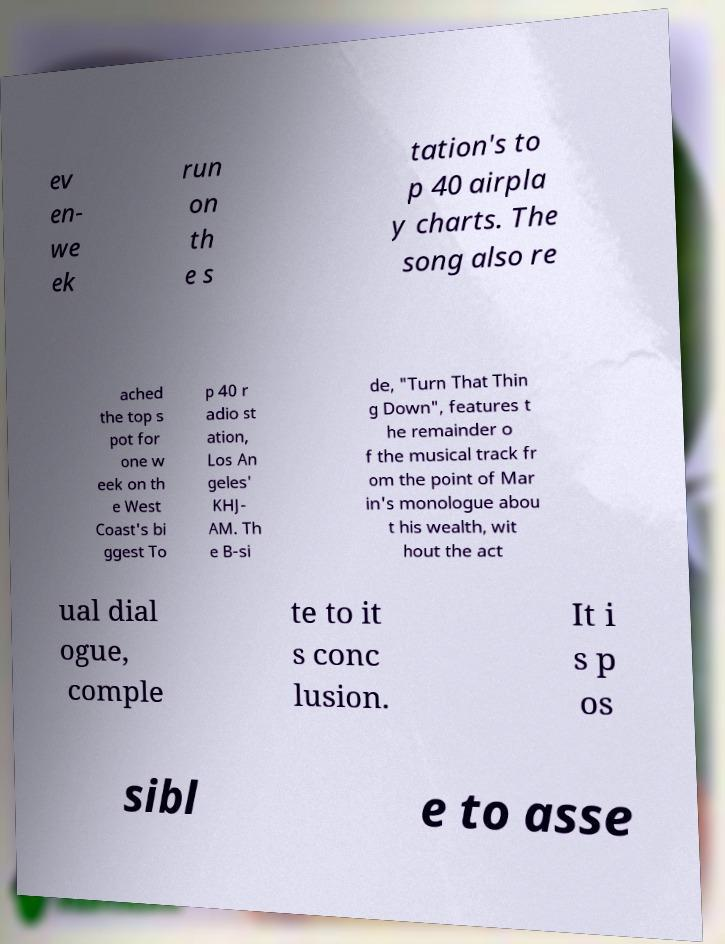Can you accurately transcribe the text from the provided image for me? ev en- we ek run on th e s tation's to p 40 airpla y charts. The song also re ached the top s pot for one w eek on th e West Coast's bi ggest To p 40 r adio st ation, Los An geles' KHJ- AM. Th e B-si de, "Turn That Thin g Down", features t he remainder o f the musical track fr om the point of Mar in's monologue abou t his wealth, wit hout the act ual dial ogue, comple te to it s conc lusion. It i s p os sibl e to asse 